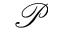Convert formula to latex. <formula><loc_0><loc_0><loc_500><loc_500>\mathcal { P }</formula> 